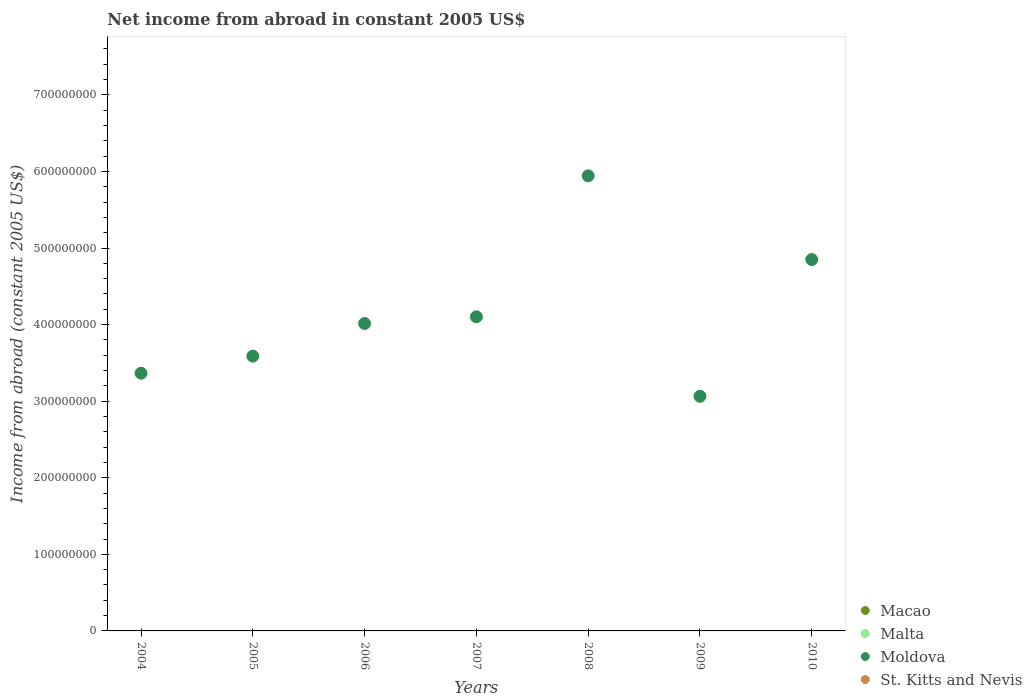How many different coloured dotlines are there?
Give a very brief answer. 1. Across all years, what is the maximum net income from abroad in Moldova?
Provide a short and direct response. 5.94e+08. Across all years, what is the minimum net income from abroad in St. Kitts and Nevis?
Provide a short and direct response. 0. What is the difference between the net income from abroad in Moldova in 2007 and that in 2010?
Offer a very short reply. -7.48e+07. What is the average net income from abroad in Macao per year?
Make the answer very short. 0. What is the ratio of the net income from abroad in Moldova in 2007 to that in 2009?
Your answer should be very brief. 1.34. Is the net income from abroad in Moldova in 2006 less than that in 2008?
Your response must be concise. Yes. What is the difference between the highest and the second highest net income from abroad in Moldova?
Your response must be concise. 1.09e+08. What is the difference between the highest and the lowest net income from abroad in Moldova?
Keep it short and to the point. 2.88e+08. Is it the case that in every year, the sum of the net income from abroad in Moldova and net income from abroad in Malta  is greater than the sum of net income from abroad in Macao and net income from abroad in St. Kitts and Nevis?
Offer a terse response. Yes. Is it the case that in every year, the sum of the net income from abroad in St. Kitts and Nevis and net income from abroad in Moldova  is greater than the net income from abroad in Malta?
Your answer should be very brief. Yes. Does the net income from abroad in Malta monotonically increase over the years?
Your response must be concise. No. Is the net income from abroad in Malta strictly less than the net income from abroad in Macao over the years?
Your answer should be compact. No. Does the graph contain grids?
Ensure brevity in your answer.  No. Where does the legend appear in the graph?
Your answer should be very brief. Bottom right. What is the title of the graph?
Keep it short and to the point. Net income from abroad in constant 2005 US$. What is the label or title of the X-axis?
Keep it short and to the point. Years. What is the label or title of the Y-axis?
Keep it short and to the point. Income from abroad (constant 2005 US$). What is the Income from abroad (constant 2005 US$) in Macao in 2004?
Your answer should be compact. 0. What is the Income from abroad (constant 2005 US$) in Moldova in 2004?
Provide a short and direct response. 3.37e+08. What is the Income from abroad (constant 2005 US$) in Moldova in 2005?
Your answer should be very brief. 3.59e+08. What is the Income from abroad (constant 2005 US$) in Malta in 2006?
Make the answer very short. 0. What is the Income from abroad (constant 2005 US$) in Moldova in 2006?
Provide a short and direct response. 4.01e+08. What is the Income from abroad (constant 2005 US$) in St. Kitts and Nevis in 2006?
Make the answer very short. 0. What is the Income from abroad (constant 2005 US$) in Malta in 2007?
Provide a succinct answer. 0. What is the Income from abroad (constant 2005 US$) in Moldova in 2007?
Your response must be concise. 4.10e+08. What is the Income from abroad (constant 2005 US$) in St. Kitts and Nevis in 2007?
Your answer should be very brief. 0. What is the Income from abroad (constant 2005 US$) in Moldova in 2008?
Your answer should be very brief. 5.94e+08. What is the Income from abroad (constant 2005 US$) in St. Kitts and Nevis in 2008?
Offer a very short reply. 0. What is the Income from abroad (constant 2005 US$) in Malta in 2009?
Your answer should be very brief. 0. What is the Income from abroad (constant 2005 US$) in Moldova in 2009?
Provide a succinct answer. 3.06e+08. What is the Income from abroad (constant 2005 US$) of St. Kitts and Nevis in 2009?
Make the answer very short. 0. What is the Income from abroad (constant 2005 US$) in Macao in 2010?
Offer a terse response. 0. What is the Income from abroad (constant 2005 US$) of Malta in 2010?
Offer a very short reply. 0. What is the Income from abroad (constant 2005 US$) of Moldova in 2010?
Offer a terse response. 4.85e+08. What is the Income from abroad (constant 2005 US$) in St. Kitts and Nevis in 2010?
Provide a succinct answer. 0. Across all years, what is the maximum Income from abroad (constant 2005 US$) of Moldova?
Make the answer very short. 5.94e+08. Across all years, what is the minimum Income from abroad (constant 2005 US$) of Moldova?
Provide a succinct answer. 3.06e+08. What is the total Income from abroad (constant 2005 US$) in Moldova in the graph?
Give a very brief answer. 2.89e+09. What is the total Income from abroad (constant 2005 US$) in St. Kitts and Nevis in the graph?
Keep it short and to the point. 0. What is the difference between the Income from abroad (constant 2005 US$) of Moldova in 2004 and that in 2005?
Offer a terse response. -2.23e+07. What is the difference between the Income from abroad (constant 2005 US$) in Moldova in 2004 and that in 2006?
Your response must be concise. -6.49e+07. What is the difference between the Income from abroad (constant 2005 US$) of Moldova in 2004 and that in 2007?
Offer a very short reply. -7.37e+07. What is the difference between the Income from abroad (constant 2005 US$) in Moldova in 2004 and that in 2008?
Provide a succinct answer. -2.58e+08. What is the difference between the Income from abroad (constant 2005 US$) of Moldova in 2004 and that in 2009?
Offer a terse response. 3.02e+07. What is the difference between the Income from abroad (constant 2005 US$) of Moldova in 2004 and that in 2010?
Offer a terse response. -1.48e+08. What is the difference between the Income from abroad (constant 2005 US$) in Moldova in 2005 and that in 2006?
Offer a very short reply. -4.26e+07. What is the difference between the Income from abroad (constant 2005 US$) of Moldova in 2005 and that in 2007?
Offer a very short reply. -5.14e+07. What is the difference between the Income from abroad (constant 2005 US$) in Moldova in 2005 and that in 2008?
Keep it short and to the point. -2.35e+08. What is the difference between the Income from abroad (constant 2005 US$) of Moldova in 2005 and that in 2009?
Make the answer very short. 5.25e+07. What is the difference between the Income from abroad (constant 2005 US$) in Moldova in 2005 and that in 2010?
Your answer should be compact. -1.26e+08. What is the difference between the Income from abroad (constant 2005 US$) in Moldova in 2006 and that in 2007?
Make the answer very short. -8.77e+06. What is the difference between the Income from abroad (constant 2005 US$) of Moldova in 2006 and that in 2008?
Your answer should be very brief. -1.93e+08. What is the difference between the Income from abroad (constant 2005 US$) of Moldova in 2006 and that in 2009?
Your answer should be very brief. 9.51e+07. What is the difference between the Income from abroad (constant 2005 US$) of Moldova in 2006 and that in 2010?
Provide a short and direct response. -8.35e+07. What is the difference between the Income from abroad (constant 2005 US$) of Moldova in 2007 and that in 2008?
Offer a very short reply. -1.84e+08. What is the difference between the Income from abroad (constant 2005 US$) in Moldova in 2007 and that in 2009?
Your answer should be compact. 1.04e+08. What is the difference between the Income from abroad (constant 2005 US$) in Moldova in 2007 and that in 2010?
Make the answer very short. -7.48e+07. What is the difference between the Income from abroad (constant 2005 US$) in Moldova in 2008 and that in 2009?
Offer a terse response. 2.88e+08. What is the difference between the Income from abroad (constant 2005 US$) in Moldova in 2008 and that in 2010?
Your answer should be compact. 1.09e+08. What is the difference between the Income from abroad (constant 2005 US$) of Moldova in 2009 and that in 2010?
Offer a very short reply. -1.79e+08. What is the average Income from abroad (constant 2005 US$) of Malta per year?
Give a very brief answer. 0. What is the average Income from abroad (constant 2005 US$) of Moldova per year?
Provide a succinct answer. 4.13e+08. What is the ratio of the Income from abroad (constant 2005 US$) in Moldova in 2004 to that in 2005?
Provide a succinct answer. 0.94. What is the ratio of the Income from abroad (constant 2005 US$) of Moldova in 2004 to that in 2006?
Provide a succinct answer. 0.84. What is the ratio of the Income from abroad (constant 2005 US$) of Moldova in 2004 to that in 2007?
Keep it short and to the point. 0.82. What is the ratio of the Income from abroad (constant 2005 US$) in Moldova in 2004 to that in 2008?
Provide a succinct answer. 0.57. What is the ratio of the Income from abroad (constant 2005 US$) in Moldova in 2004 to that in 2009?
Provide a succinct answer. 1.1. What is the ratio of the Income from abroad (constant 2005 US$) in Moldova in 2004 to that in 2010?
Your response must be concise. 0.69. What is the ratio of the Income from abroad (constant 2005 US$) in Moldova in 2005 to that in 2006?
Give a very brief answer. 0.89. What is the ratio of the Income from abroad (constant 2005 US$) of Moldova in 2005 to that in 2007?
Provide a succinct answer. 0.87. What is the ratio of the Income from abroad (constant 2005 US$) of Moldova in 2005 to that in 2008?
Keep it short and to the point. 0.6. What is the ratio of the Income from abroad (constant 2005 US$) of Moldova in 2005 to that in 2009?
Your answer should be very brief. 1.17. What is the ratio of the Income from abroad (constant 2005 US$) in Moldova in 2005 to that in 2010?
Make the answer very short. 0.74. What is the ratio of the Income from abroad (constant 2005 US$) in Moldova in 2006 to that in 2007?
Keep it short and to the point. 0.98. What is the ratio of the Income from abroad (constant 2005 US$) in Moldova in 2006 to that in 2008?
Ensure brevity in your answer.  0.68. What is the ratio of the Income from abroad (constant 2005 US$) of Moldova in 2006 to that in 2009?
Your response must be concise. 1.31. What is the ratio of the Income from abroad (constant 2005 US$) in Moldova in 2006 to that in 2010?
Give a very brief answer. 0.83. What is the ratio of the Income from abroad (constant 2005 US$) in Moldova in 2007 to that in 2008?
Your response must be concise. 0.69. What is the ratio of the Income from abroad (constant 2005 US$) of Moldova in 2007 to that in 2009?
Ensure brevity in your answer.  1.34. What is the ratio of the Income from abroad (constant 2005 US$) in Moldova in 2007 to that in 2010?
Offer a terse response. 0.85. What is the ratio of the Income from abroad (constant 2005 US$) in Moldova in 2008 to that in 2009?
Give a very brief answer. 1.94. What is the ratio of the Income from abroad (constant 2005 US$) of Moldova in 2008 to that in 2010?
Ensure brevity in your answer.  1.23. What is the ratio of the Income from abroad (constant 2005 US$) of Moldova in 2009 to that in 2010?
Ensure brevity in your answer.  0.63. What is the difference between the highest and the second highest Income from abroad (constant 2005 US$) in Moldova?
Your answer should be very brief. 1.09e+08. What is the difference between the highest and the lowest Income from abroad (constant 2005 US$) in Moldova?
Ensure brevity in your answer.  2.88e+08. 